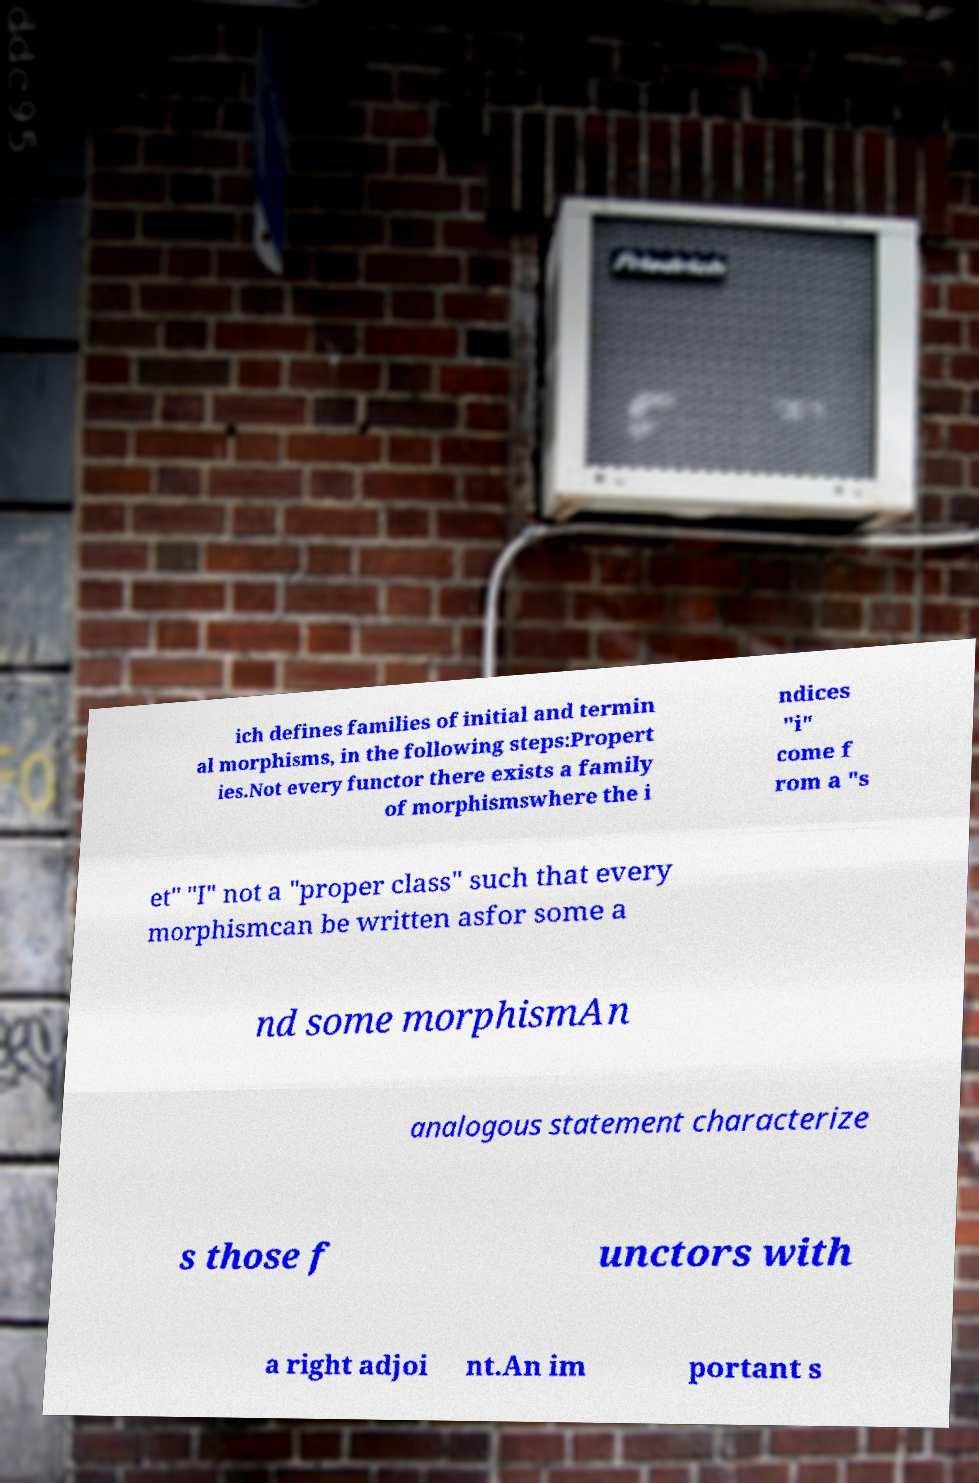What messages or text are displayed in this image? I need them in a readable, typed format. ich defines families of initial and termin al morphisms, in the following steps:Propert ies.Not every functor there exists a family of morphismswhere the i ndices "i" come f rom a "s et" "I" not a "proper class" such that every morphismcan be written asfor some a nd some morphismAn analogous statement characterize s those f unctors with a right adjoi nt.An im portant s 